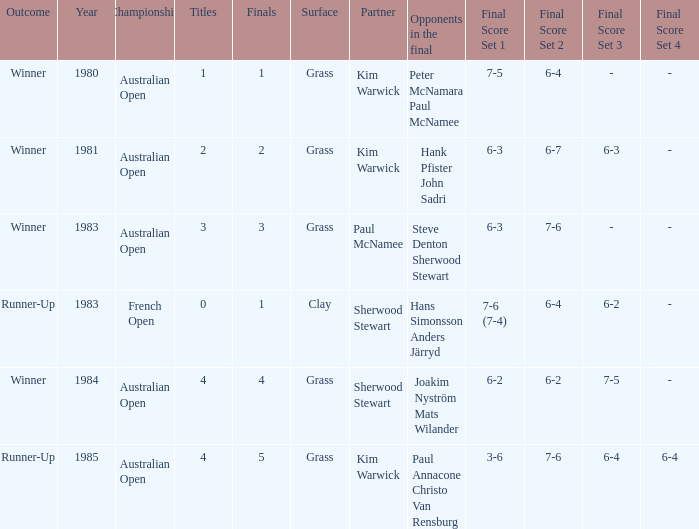How many different outcomes did the final with Paul McNamee as a partner have? 1.0. 